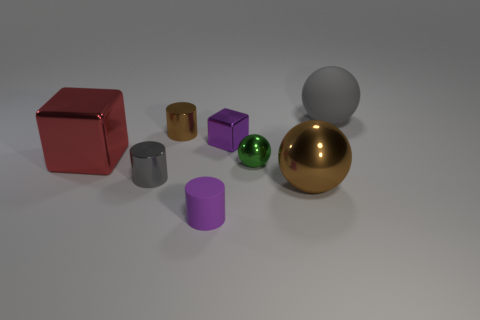Does the small metal block have the same color as the tiny rubber cylinder?
Make the answer very short. Yes. How many small metallic cubes are the same color as the tiny matte thing?
Give a very brief answer. 1. What is the size of the brown object that is on the left side of the matte thing that is to the left of the big matte object?
Offer a very short reply. Small. What is the shape of the big brown object?
Offer a terse response. Sphere. There is a cylinder behind the tiny sphere; what material is it?
Offer a very short reply. Metal. There is a matte object that is in front of the matte thing behind the small thing in front of the tiny gray object; what is its color?
Give a very brief answer. Purple. The matte cylinder that is the same size as the purple metal cube is what color?
Provide a succinct answer. Purple. How many shiny things are either big gray things or brown cubes?
Your response must be concise. 0. What is the color of the small sphere that is the same material as the large block?
Provide a succinct answer. Green. What is the brown thing left of the small cylinder to the right of the tiny brown object made of?
Offer a terse response. Metal. 